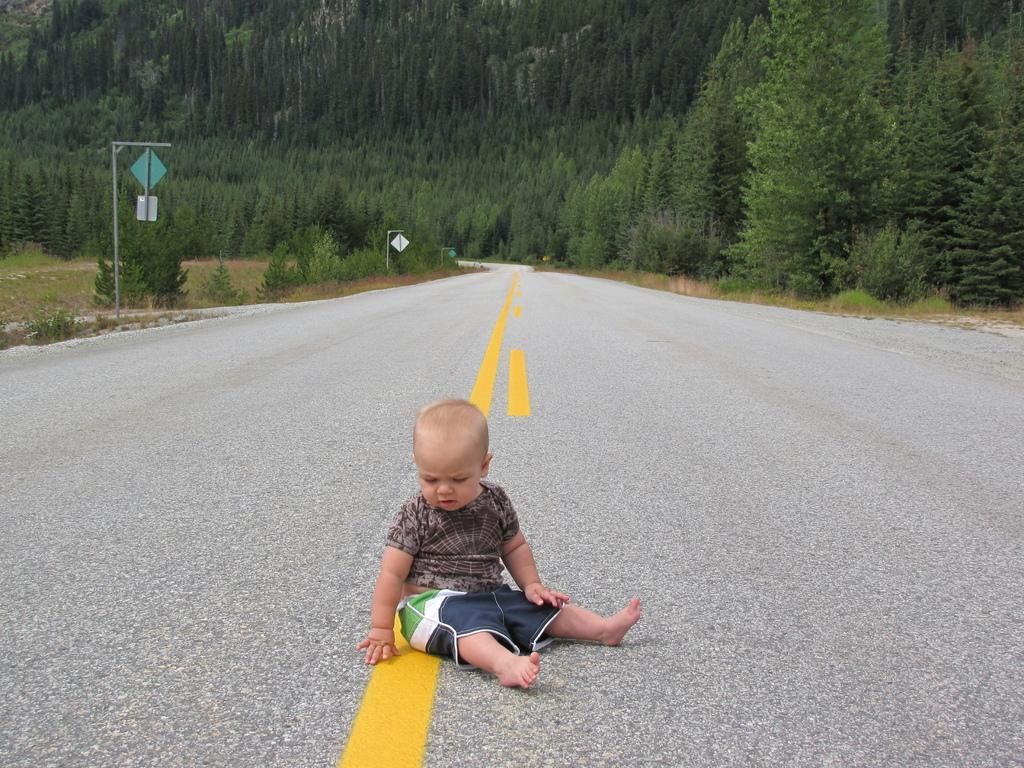What is the child doing in the image? The child is sitting on the road in the image. What structures can be seen in the image? There are poles and boards visible in the image. What type of vegetation is present in the image? There are green trees in the image. What type of beetle can be seen crawling on the child's nose in the image? There is no beetle present on the child's nose in the image. What song is the child singing in the image? There is no indication in the image that the child is singing a song. 